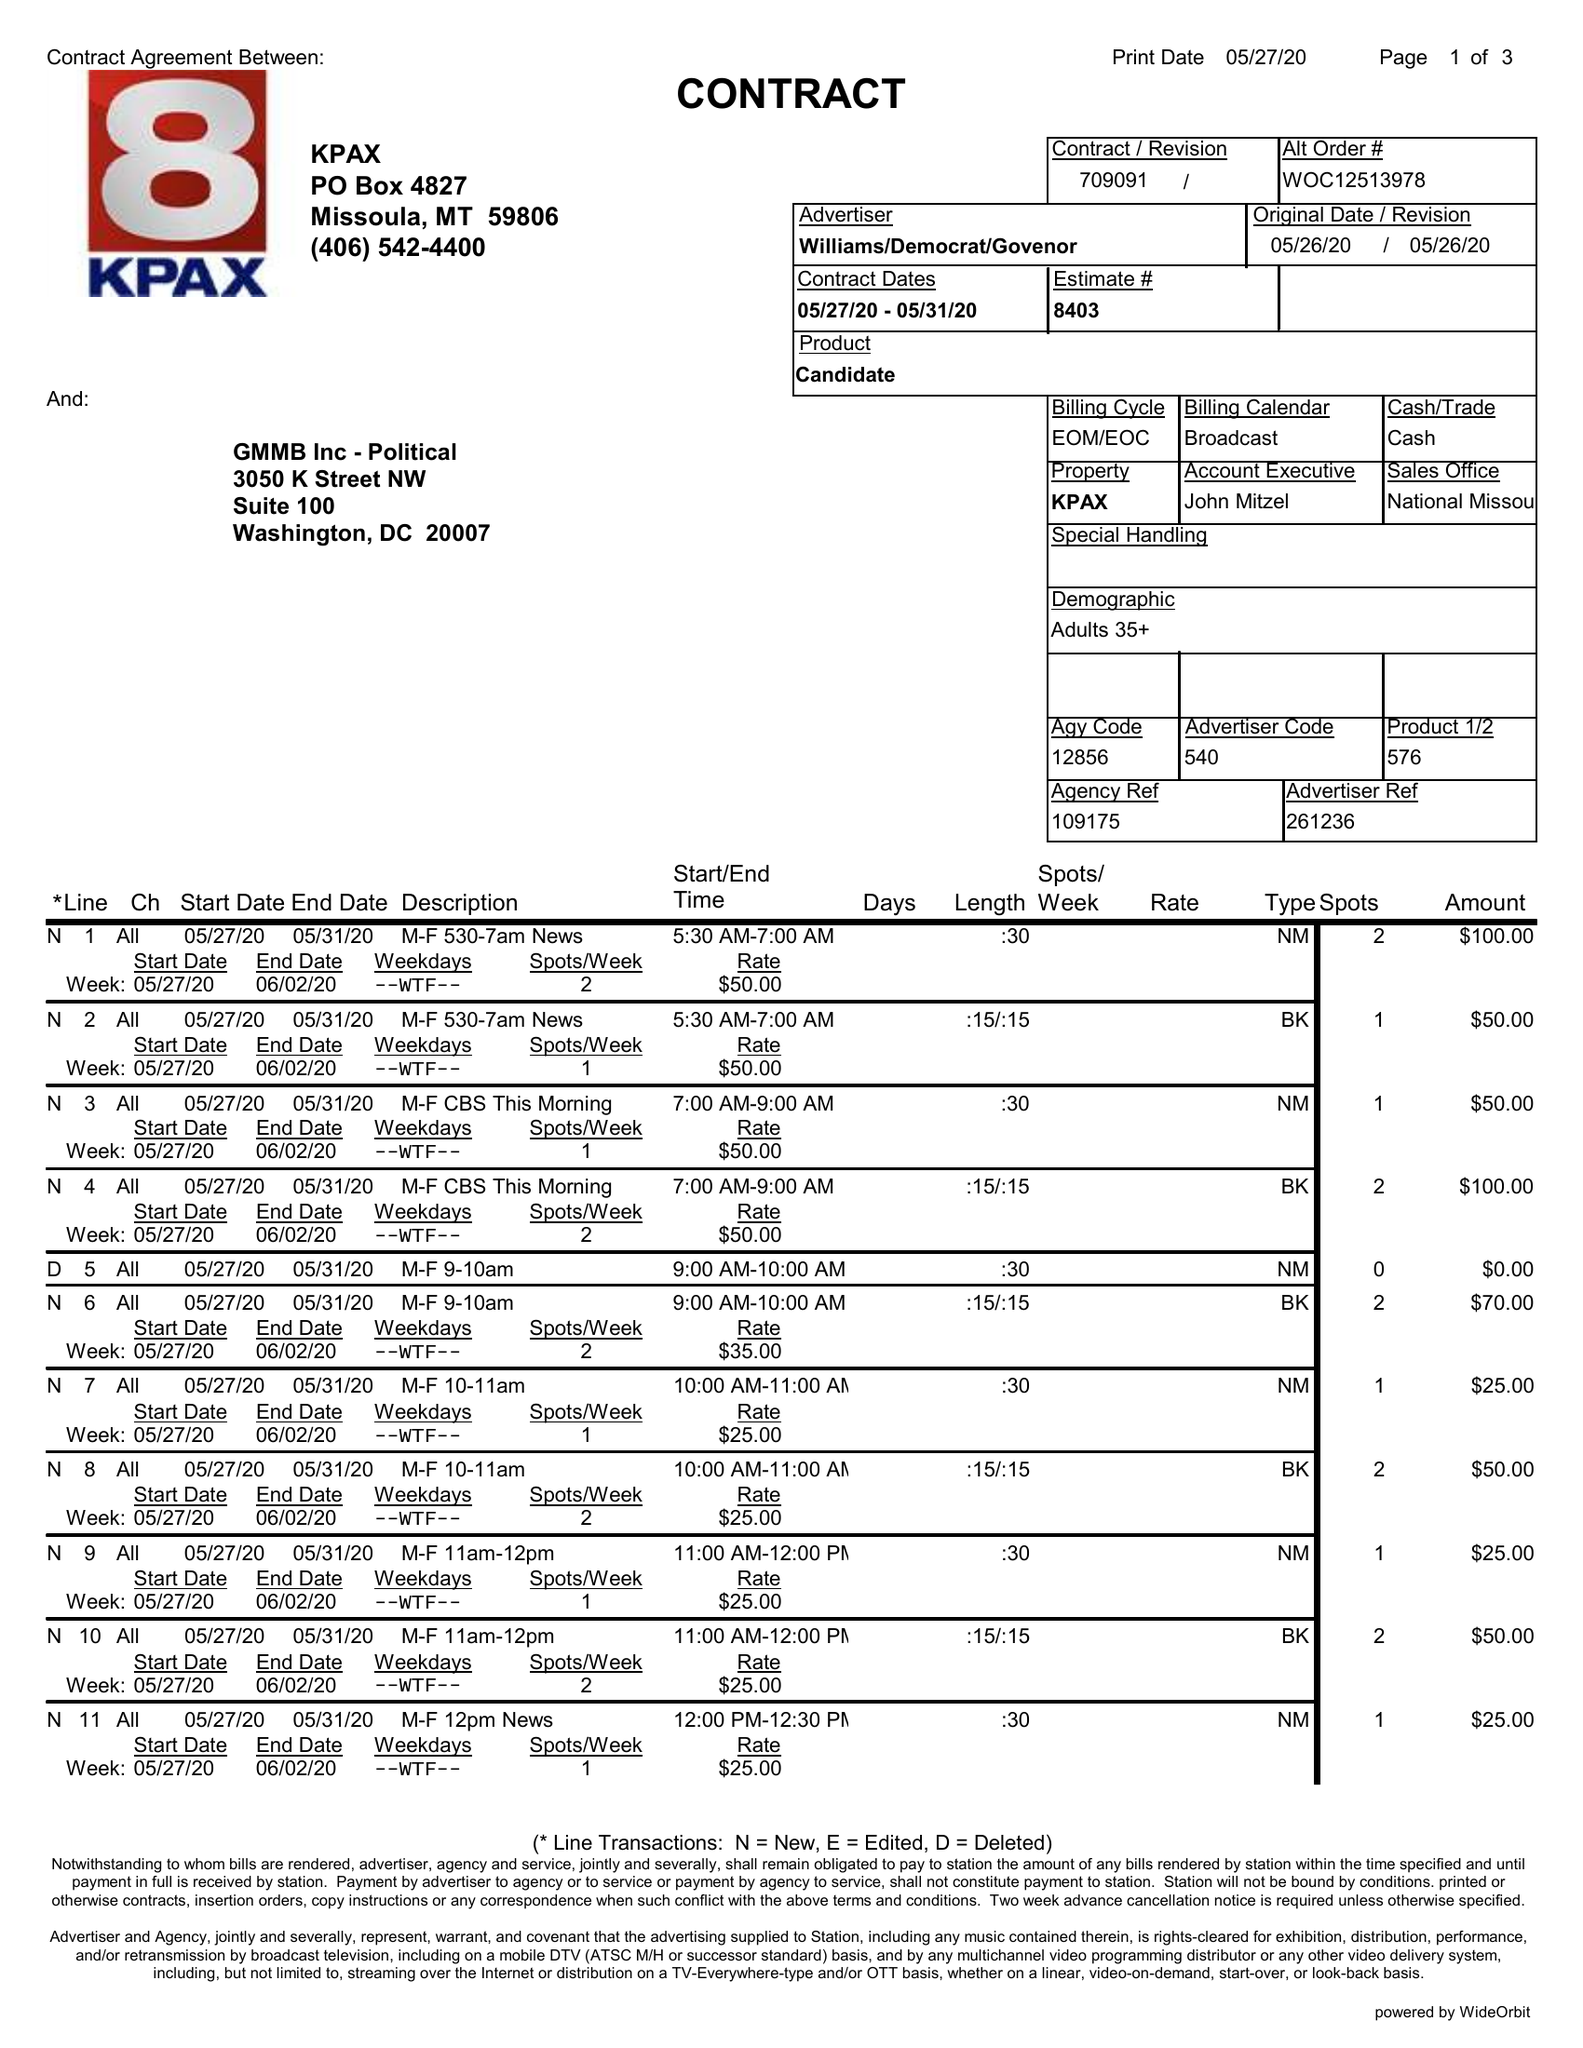What is the value for the flight_from?
Answer the question using a single word or phrase. 05/27/20 